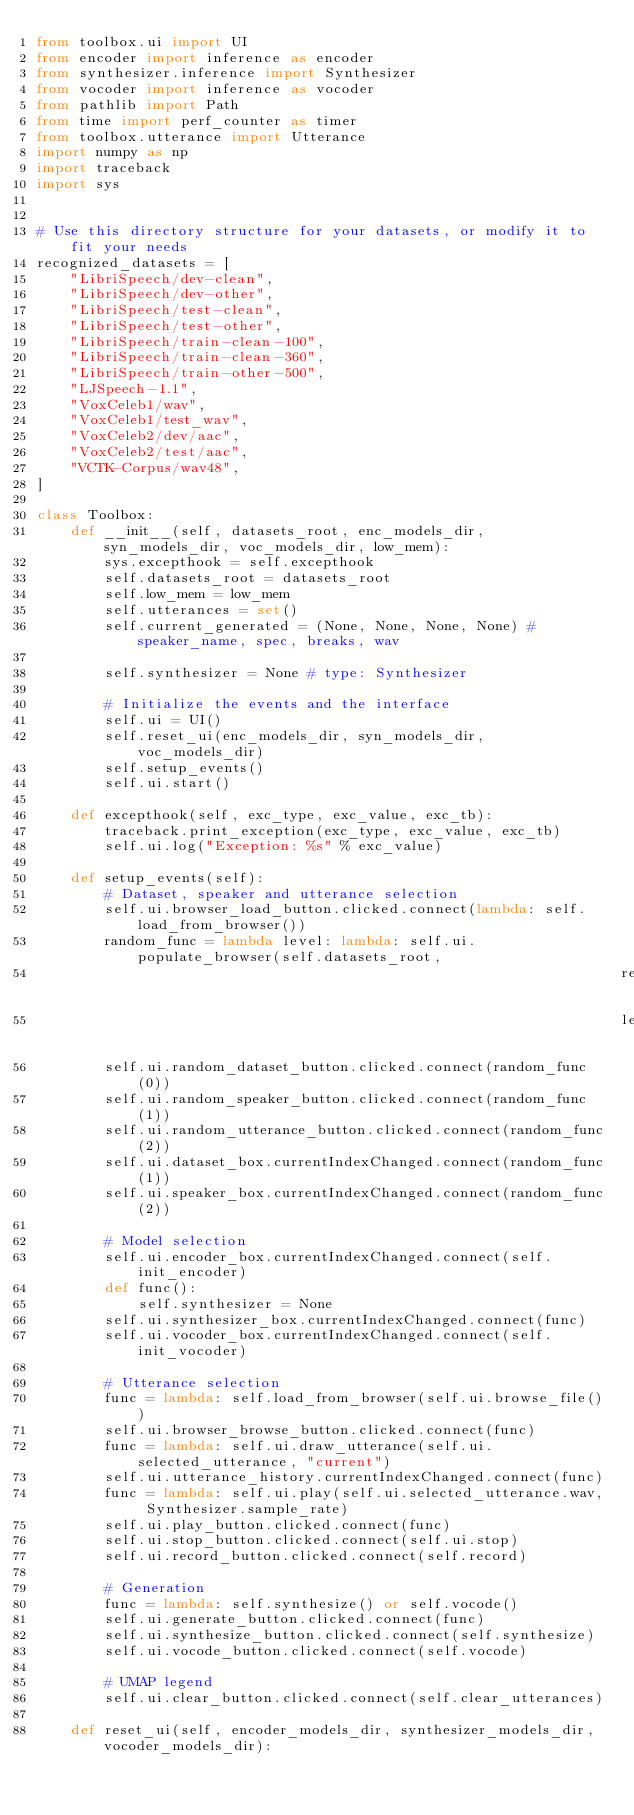Convert code to text. <code><loc_0><loc_0><loc_500><loc_500><_Python_>from toolbox.ui import UI
from encoder import inference as encoder
from synthesizer.inference import Synthesizer
from vocoder import inference as vocoder
from pathlib import Path
from time import perf_counter as timer
from toolbox.utterance import Utterance
import numpy as np
import traceback
import sys


# Use this directory structure for your datasets, or modify it to fit your needs
recognized_datasets = [
    "LibriSpeech/dev-clean",
    "LibriSpeech/dev-other",
    "LibriSpeech/test-clean",
    "LibriSpeech/test-other",
    "LibriSpeech/train-clean-100",
    "LibriSpeech/train-clean-360",
    "LibriSpeech/train-other-500",
    "LJSpeech-1.1",
    "VoxCeleb1/wav",
    "VoxCeleb1/test_wav",
    "VoxCeleb2/dev/aac",
    "VoxCeleb2/test/aac",
    "VCTK-Corpus/wav48",
]

class Toolbox:
    def __init__(self, datasets_root, enc_models_dir, syn_models_dir, voc_models_dir, low_mem):
        sys.excepthook = self.excepthook
        self.datasets_root = datasets_root
        self.low_mem = low_mem
        self.utterances = set()
        self.current_generated = (None, None, None, None) # speaker_name, spec, breaks, wav
        
        self.synthesizer = None # type: Synthesizer
        
        # Initialize the events and the interface
        self.ui = UI()
        self.reset_ui(enc_models_dir, syn_models_dir, voc_models_dir)
        self.setup_events()
        self.ui.start()
        
    def excepthook(self, exc_type, exc_value, exc_tb):
        traceback.print_exception(exc_type, exc_value, exc_tb)
        self.ui.log("Exception: %s" % exc_value)
        
    def setup_events(self):
        # Dataset, speaker and utterance selection
        self.ui.browser_load_button.clicked.connect(lambda: self.load_from_browser())
        random_func = lambda level: lambda: self.ui.populate_browser(self.datasets_root,
                                                                     recognized_datasets,
                                                                     level)
        self.ui.random_dataset_button.clicked.connect(random_func(0))
        self.ui.random_speaker_button.clicked.connect(random_func(1))
        self.ui.random_utterance_button.clicked.connect(random_func(2))
        self.ui.dataset_box.currentIndexChanged.connect(random_func(1))
        self.ui.speaker_box.currentIndexChanged.connect(random_func(2))
        
        # Model selection
        self.ui.encoder_box.currentIndexChanged.connect(self.init_encoder)
        def func(): 
            self.synthesizer = None
        self.ui.synthesizer_box.currentIndexChanged.connect(func)
        self.ui.vocoder_box.currentIndexChanged.connect(self.init_vocoder)
        
        # Utterance selection
        func = lambda: self.load_from_browser(self.ui.browse_file())
        self.ui.browser_browse_button.clicked.connect(func)
        func = lambda: self.ui.draw_utterance(self.ui.selected_utterance, "current")
        self.ui.utterance_history.currentIndexChanged.connect(func)
        func = lambda: self.ui.play(self.ui.selected_utterance.wav, Synthesizer.sample_rate)
        self.ui.play_button.clicked.connect(func)
        self.ui.stop_button.clicked.connect(self.ui.stop)
        self.ui.record_button.clicked.connect(self.record)
        
        # Generation
        func = lambda: self.synthesize() or self.vocode()
        self.ui.generate_button.clicked.connect(func)
        self.ui.synthesize_button.clicked.connect(self.synthesize)
        self.ui.vocode_button.clicked.connect(self.vocode)
        
        # UMAP legend
        self.ui.clear_button.clicked.connect(self.clear_utterances)

    def reset_ui(self, encoder_models_dir, synthesizer_models_dir, vocoder_models_dir):</code> 